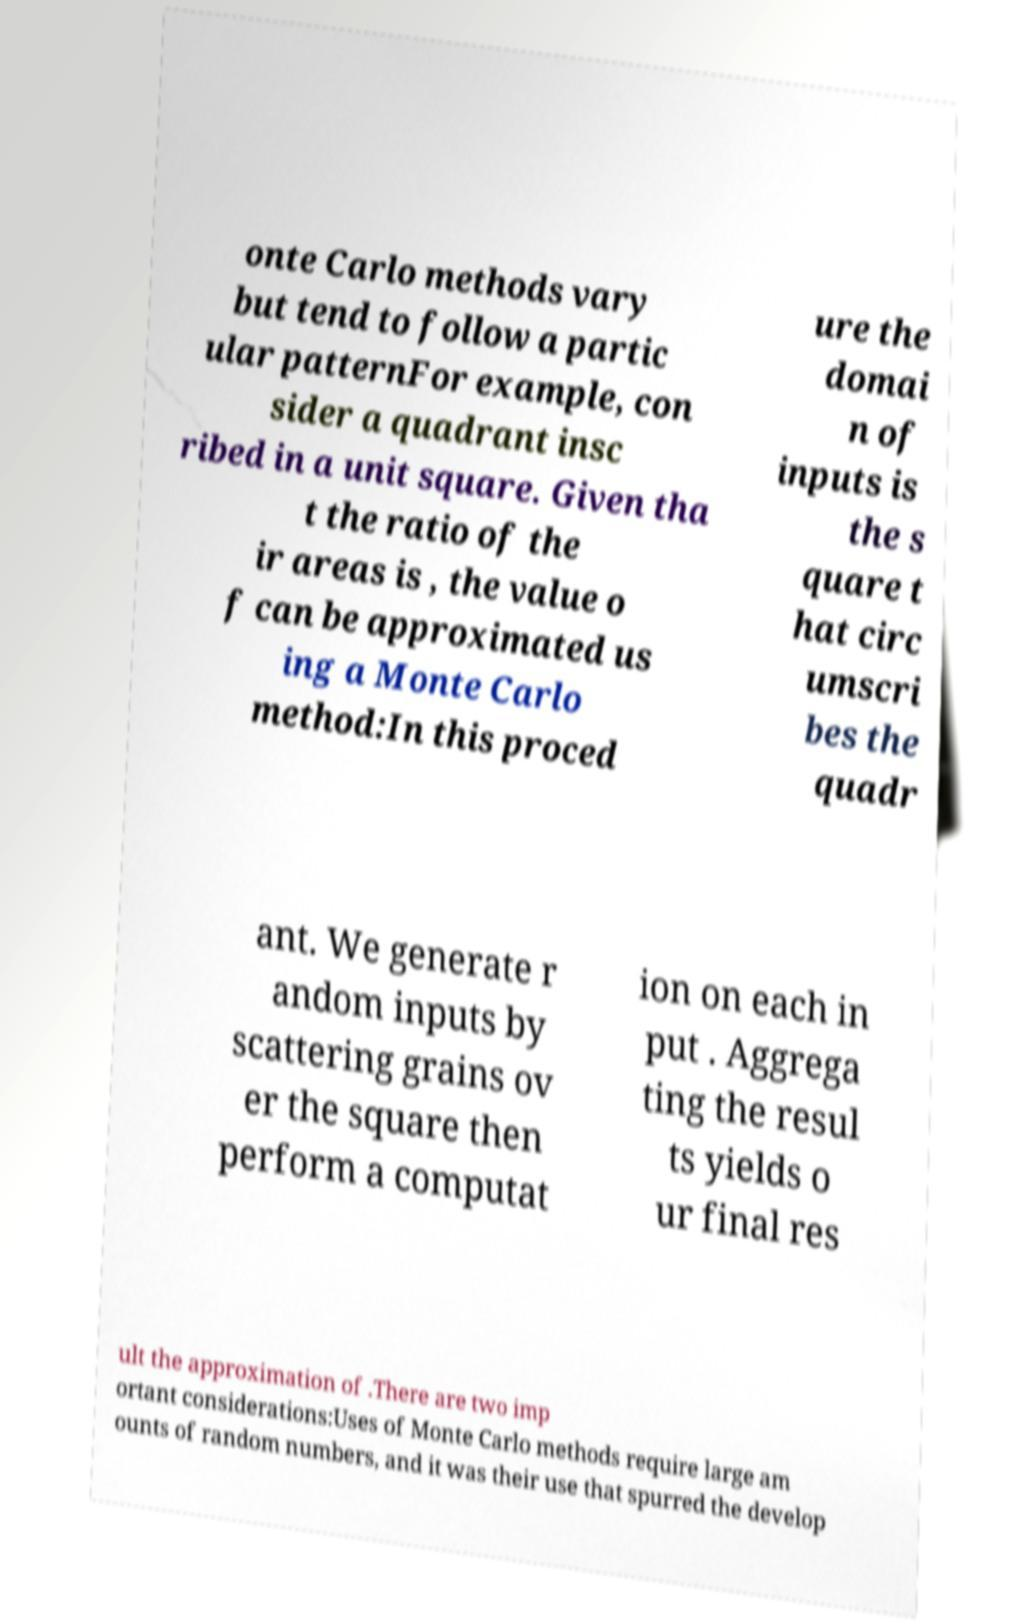Please identify and transcribe the text found in this image. onte Carlo methods vary but tend to follow a partic ular patternFor example, con sider a quadrant insc ribed in a unit square. Given tha t the ratio of the ir areas is , the value o f can be approximated us ing a Monte Carlo method:In this proced ure the domai n of inputs is the s quare t hat circ umscri bes the quadr ant. We generate r andom inputs by scattering grains ov er the square then perform a computat ion on each in put . Aggrega ting the resul ts yields o ur final res ult the approximation of .There are two imp ortant considerations:Uses of Monte Carlo methods require large am ounts of random numbers, and it was their use that spurred the develop 